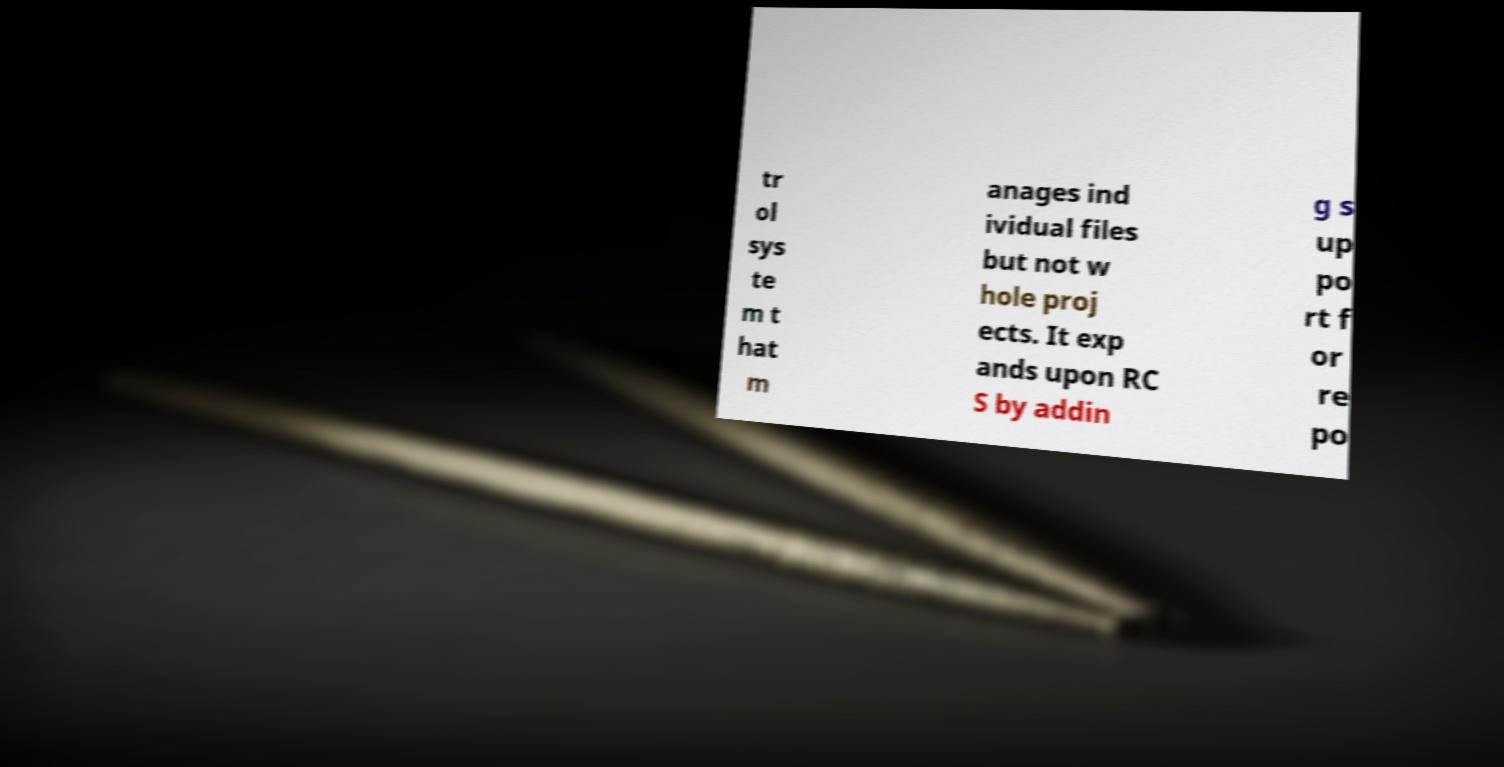What messages or text are displayed in this image? I need them in a readable, typed format. tr ol sys te m t hat m anages ind ividual files but not w hole proj ects. It exp ands upon RC S by addin g s up po rt f or re po 